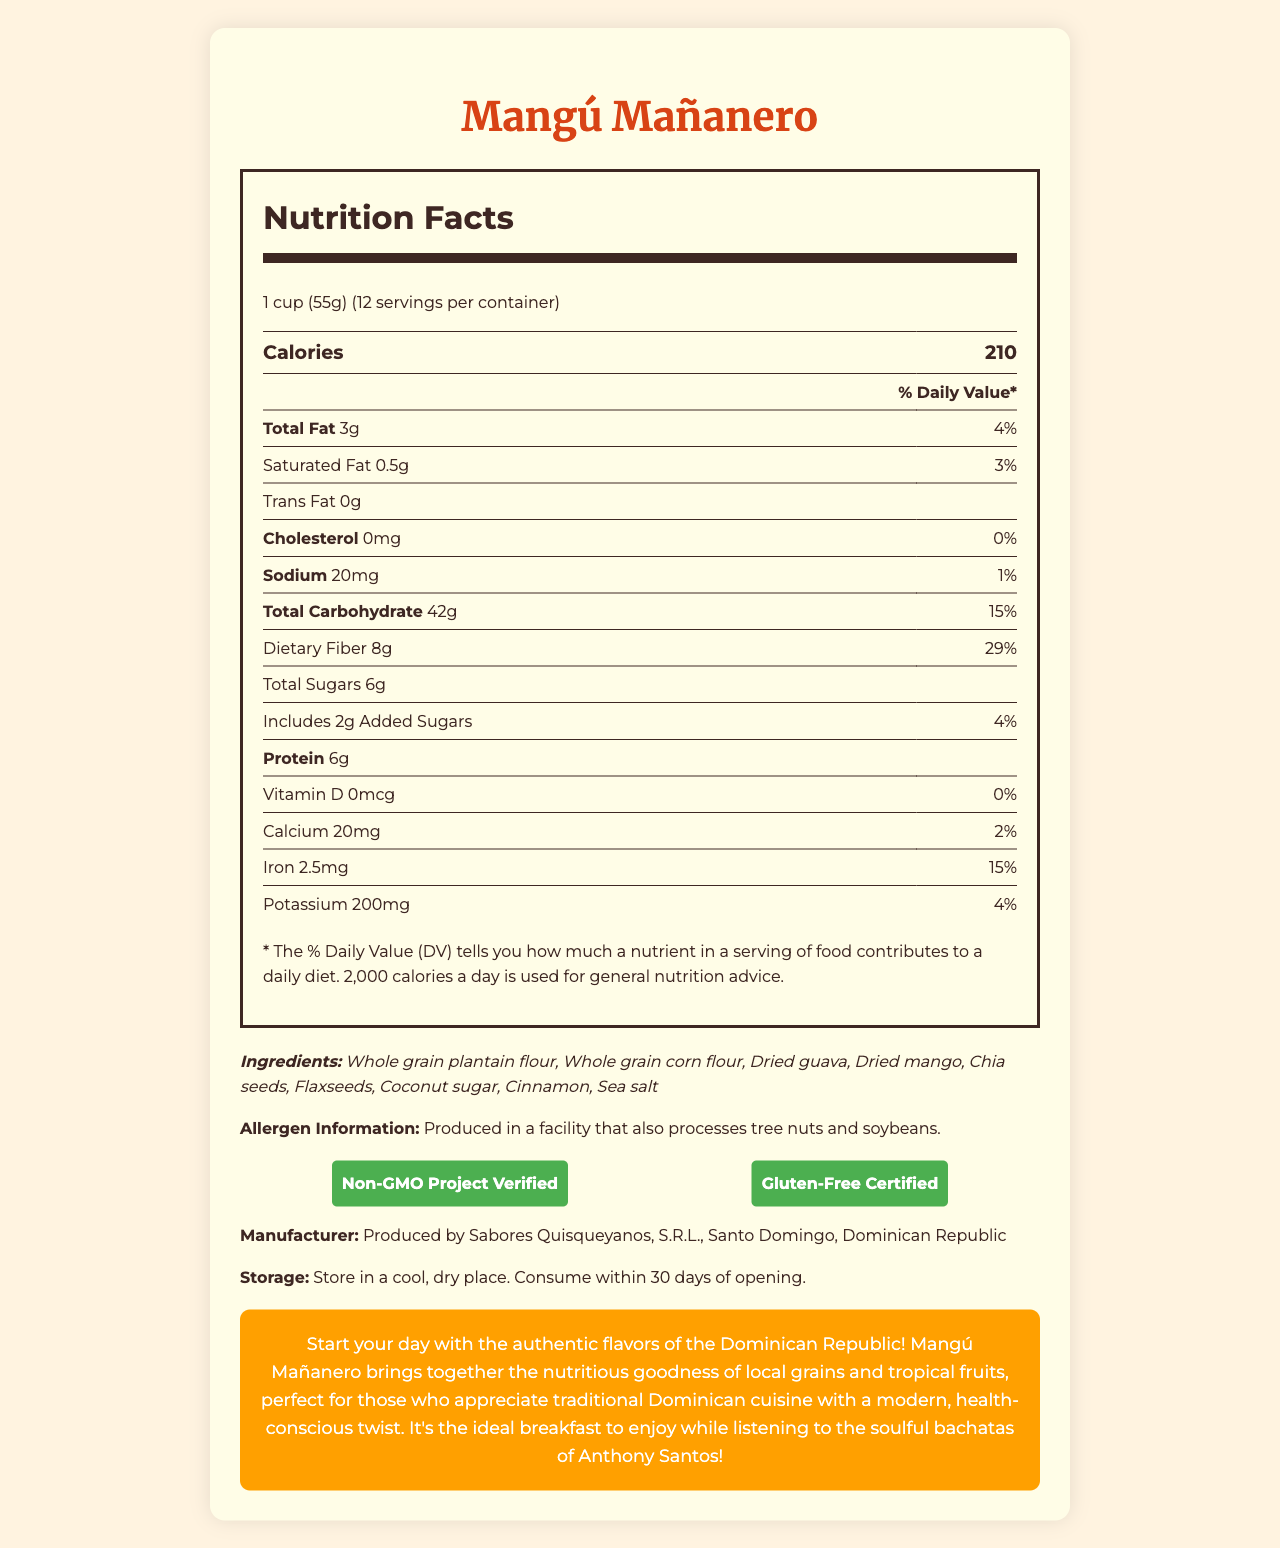what is the serving size of Mangú Mañanero? The serving size is listed at the top of the Nutrition Facts section as "1 cup (55g)."
Answer: 1 cup (55g) how many calories are in one serving? The calories per serving are indicated in large text at the beginning of the Nutrition Facts section.
Answer: 210 how much dietary fiber does one serving contain? The amount of dietary fiber is specified under the Total Carbohydrate section as "Dietary Fiber 8g."
Answer: 8g what is the daily value percentage for iron in one serving? The percentage daily value for iron is listed in the nutrition table as "Iron 15%."
Answer: 15% how many servings are in one container? The servings per container are indicated as "12" at the top of the Nutrition Facts section.
Answer: 12 which ingredient is NOT listed on the ingredients list? A. Dried guava B. Whole grain quinoa C. Chia seeds D. Dried mango Whole grain quinoa is not listed among the ingredients; the actual ingredients include whole grain plantain flour, whole grain corn flour, dried guava, dried mango, chia seeds, flaxseeds, coconut sugar, cinnamon, and sea salt.
Answer: B. Whole grain quinoa what is the total amount of sugars in one serving? The total sugars are identified as "Total Sugars 6g" under the Total Carbohydrate section.
Answer: 6g which of the following certifications does Mangú Mañanero have? A. USDA Organic B. Non-GMO Project Verified C. Fair Trade Certified D. Kosher The document states the certifications as "Non-GMO Project Verified" and "Gluten-Free Certified."
Answer: B. Non-GMO Project Verified does the product contain any trans fat? The Nutrition Facts indicate "Trans Fat 0g," meaning it does not contain any trans fat.
Answer: No please summarize the promotional text at the bottom of the page The promotional text emphasizes the authentic flavors and healthy aspects of Mangú Mañanero, combining traditional elements of Dominican cuisine with a modern health-conscious approach.
Answer: Mangú Mañanero offers a healthy and traditional Dominican breakfast experience with local grains and fruits, ideal for those who enjoy Dominican cuisine while being health-conscious. The product is highlighted as perfect to enjoy with Anthony Santos' bachatas. how much potassium does one serving provide? The amount of potassium is listed toward the end of the nutrition table as "Potassium 200mg."
Answer: 200mg please summarize the entire document The document is comprehensive, giving both specific nutritional data and descriptive promotional content about Mangú Mañanero, underlining its health benefits and cultural significance.
Answer: The document provides detailed nutritional information, ingredients, allergen information, certifications, manufacturer details, and storage instructions for Mangú Mañanero, a fiber-rich Dominican breakfast cereal. The nutritional facts include calories, fats, cholesterol, sodium, carbohydrates, dietary fiber, sugars, protein, and vitamins/minerals per serving. The promotional text highlights the product's traditional Dominican flavors combined with health benefits. what is the main ingredient in Mangú Mañanero? The first ingredient listed, and typically the primary ingredient by weight, is whole grain plantain flour.
Answer: Whole grain plantain flour what is the daily value percentage for saturated fat in one serving? The daily value percentage for saturated fat is listed under total fat as "Saturated Fat 0.5g, 3%."
Answer: 3% the document mentions a facility that processes which allergens? The allergen information section states that the product is produced in a facility that also processes tree nuts and soybeans.
Answer: Tree nuts and soybeans what is the amount of calcium provided in one serving? The amount of calcium is given as "Calcium 20mg" toward the end of the nutrition table.
Answer: 20mg what can you infer about the vitamin D content in Mangú Mañanero? The vitamin D content is listed as "Vitamin D 0mcg, 0%" indicating it does not provide any vitamin D.
Answer: 0mcg, 0% how should the product be stored? Storage instructions specify to keep it in a cool, dry place and to consume it within 30 days of opening.
Answer: Store in a cool, dry place. Consume within 30 days of opening. what is the fat content per serving? The total fat content per serving is listed as "Total Fat 3g."
Answer: 3g which of the following components has the highest daily value percentage? A. Total Fat B. Sodium C. Dietary Fiber D. Protein The daily value percentage for dietary fiber is 29%, which is higher than that of total fat (4%), sodium (1%), and protein (not listed with a daily percentage).
Answer: C. Dietary Fiber what is Sabores Quisqueyanos, S.R.L.? The document states that Mangú Mañanero is produced by Sabores Quisqueyanos, S.R.L., located in Santo Domingo, Dominican Republic.
Answer: The manufacturer of Mangú Mañanero are there any artificial ingredients in Mangú Mañanero? The document lists natural ingredients but does not specify whether it contains artificial ingredients, so this cannot be determined definitively.
Answer: Not enough information 